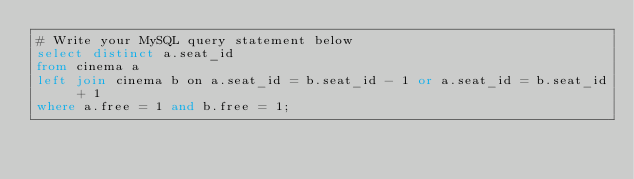<code> <loc_0><loc_0><loc_500><loc_500><_SQL_># Write your MySQL query statement below
select distinct a.seat_id 
from cinema a
left join cinema b on a.seat_id = b.seat_id - 1 or a.seat_id = b.seat_id + 1
where a.free = 1 and b.free = 1;
</code> 